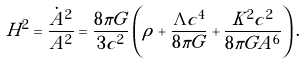Convert formula to latex. <formula><loc_0><loc_0><loc_500><loc_500>H ^ { 2 } = \frac { \dot { A } ^ { 2 } } { A ^ { 2 } } = \frac { 8 \pi G } { 3 c ^ { 2 } } \left ( \rho + \frac { \Lambda c ^ { 4 } } { 8 \pi G } + \frac { K ^ { 2 } c ^ { 2 } } { 8 \pi G A ^ { 6 } } \right ) .</formula> 